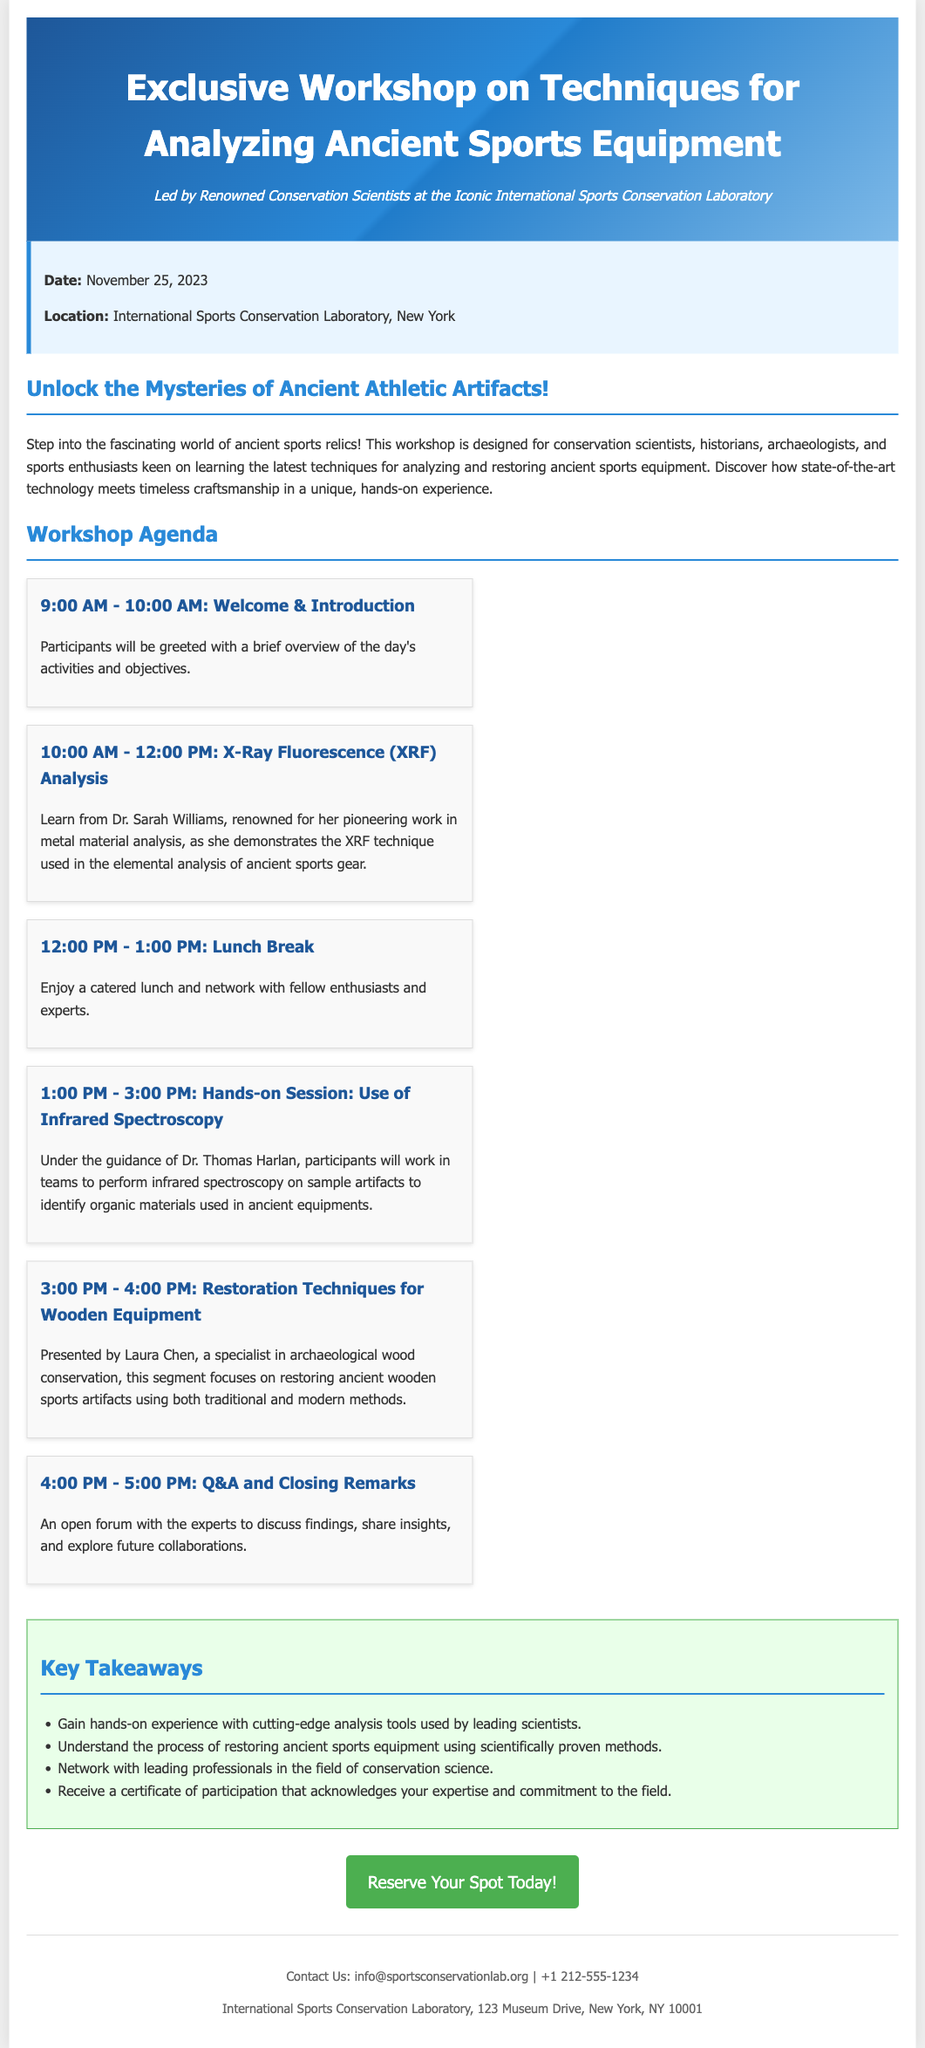What is the date of the workshop? The date of the workshop is explicitly mentioned in the document.
Answer: November 25, 2023 Where is the workshop being held? The location of the workshop is specified in the document.
Answer: International Sports Conservation Laboratory, New York Who is presenting the X-Ray Fluorescence analysis? The document names the expert conducting this session.
Answer: Dr. Sarah Williams How long is the lunch break? The document provides the duration of the lunch break.
Answer: 1 hour What will participants receive upon completion of the workshop? The document states what attendees will get at the end of the event.
Answer: Certificate of participation What is the main focus of the hands-on session? It outlines the primary activities scheduled for that workshop segment.
Answer: Infrared spectroscopy on sample artifacts How many total agenda items are listed in the workshop? The document summarizes the total number of agenda items.
Answer: Six What is the theme of the workshop? The document highlights the central topic of the event.
Answer: Analyzing Ancient Sports Equipment What type of professionals is the workshop aimed at? The audience for the workshop is indicated in the description.
Answer: Conservation scientists, historians, archaeologists, and sports enthusiasts 